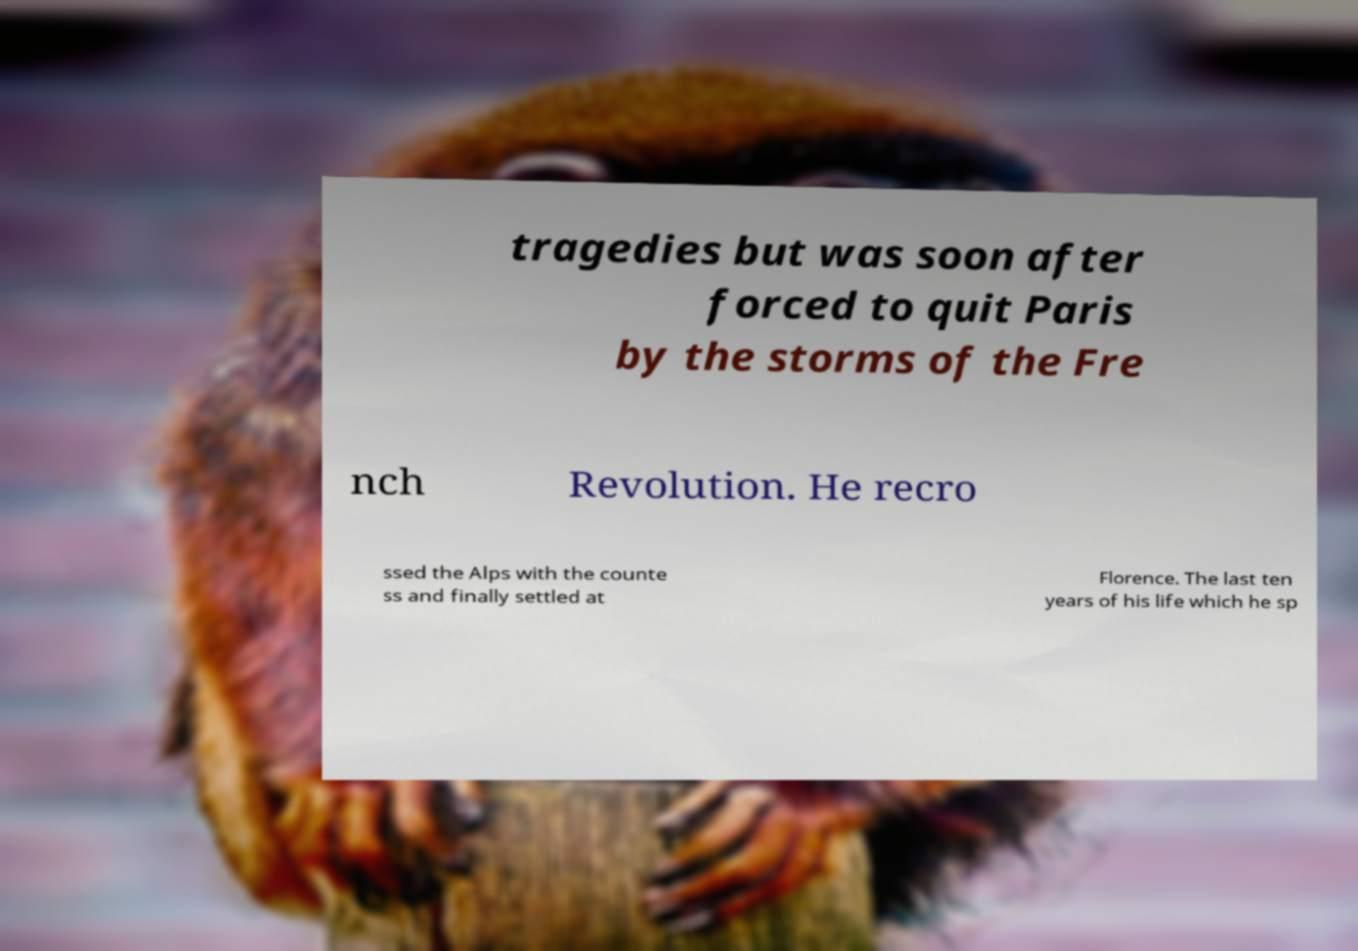Please identify and transcribe the text found in this image. tragedies but was soon after forced to quit Paris by the storms of the Fre nch Revolution. He recro ssed the Alps with the counte ss and finally settled at Florence. The last ten years of his life which he sp 